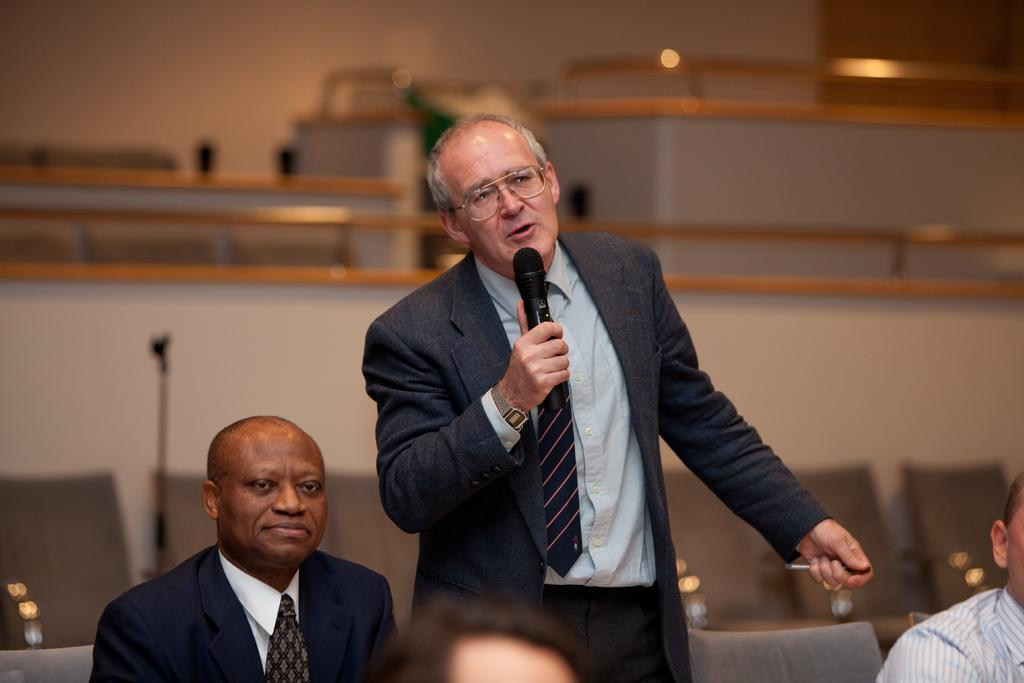What is the person in the image wearing? The person in the image is wearing a blue suit. What is the person in the blue suit doing? The person is standing and speaking in front of a microphone. Are there any other people present in the image? Yes, there are other persons sitting beside the person speaking. What type of place is the person guiding in the image? There is no indication of a place being guided in the image; the person is speaking in front of a microphone. 